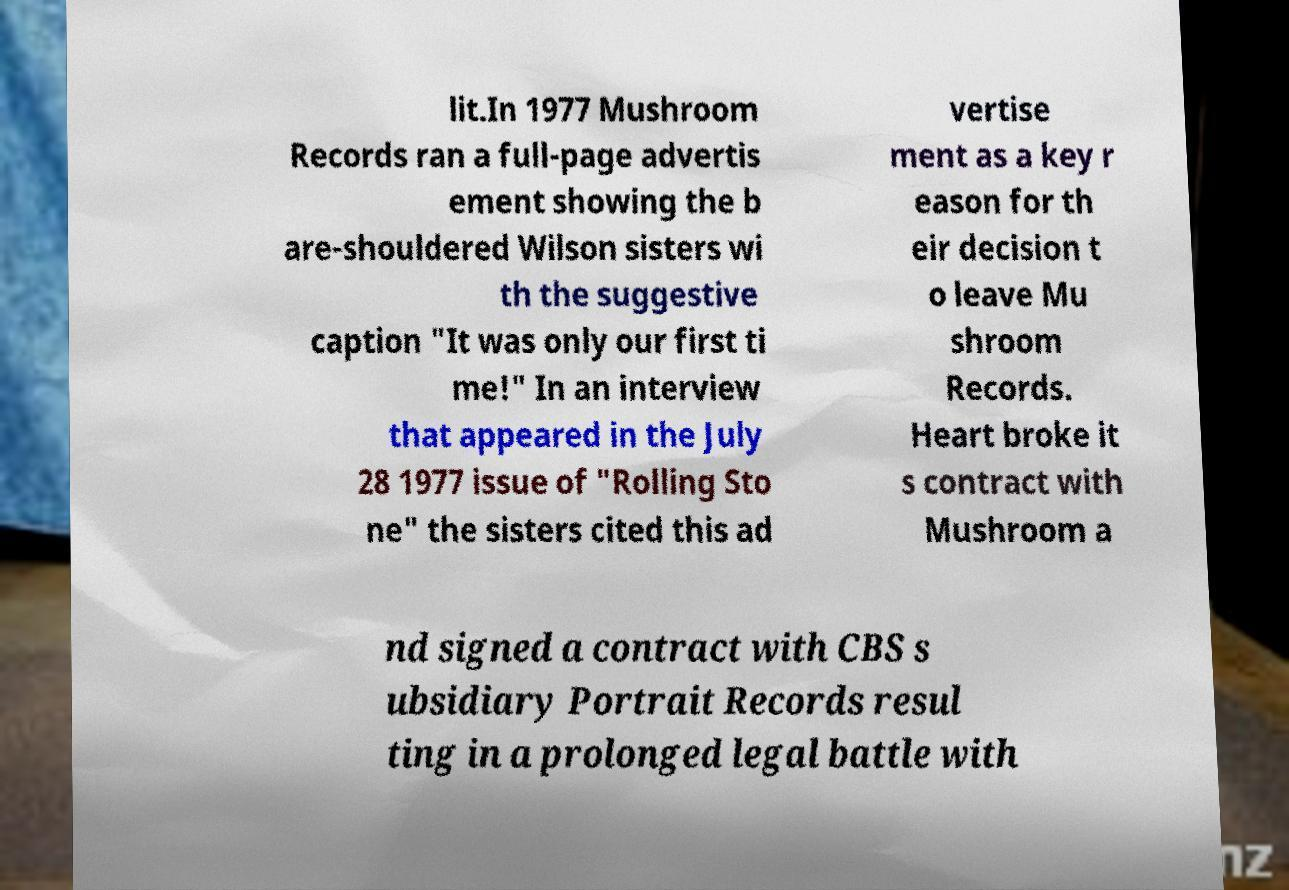Please read and relay the text visible in this image. What does it say? lit.In 1977 Mushroom Records ran a full-page advertis ement showing the b are-shouldered Wilson sisters wi th the suggestive caption "It was only our first ti me!" In an interview that appeared in the July 28 1977 issue of "Rolling Sto ne" the sisters cited this ad vertise ment as a key r eason for th eir decision t o leave Mu shroom Records. Heart broke it s contract with Mushroom a nd signed a contract with CBS s ubsidiary Portrait Records resul ting in a prolonged legal battle with 